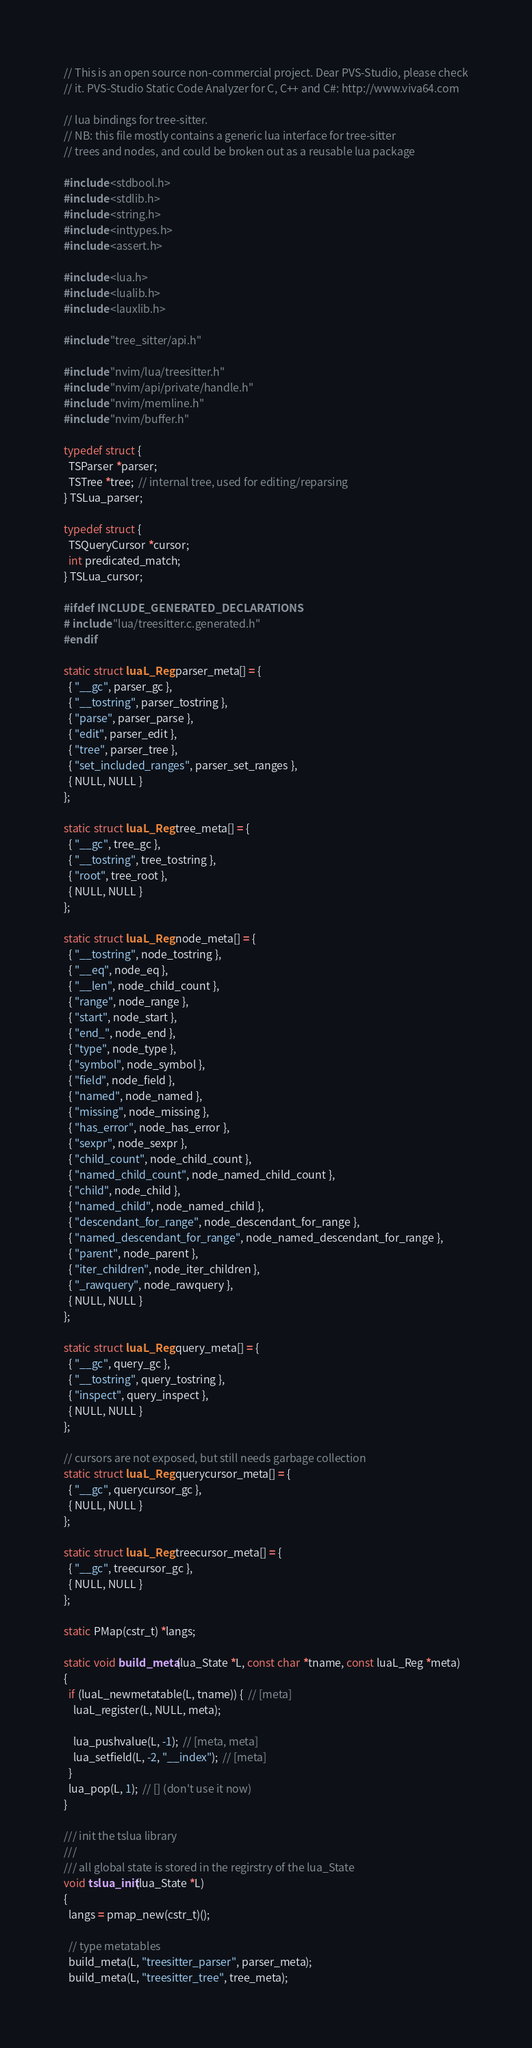Convert code to text. <code><loc_0><loc_0><loc_500><loc_500><_C_>// This is an open source non-commercial project. Dear PVS-Studio, please check
// it. PVS-Studio Static Code Analyzer for C, C++ and C#: http://www.viva64.com

// lua bindings for tree-sitter.
// NB: this file mostly contains a generic lua interface for tree-sitter
// trees and nodes, and could be broken out as a reusable lua package

#include <stdbool.h>
#include <stdlib.h>
#include <string.h>
#include <inttypes.h>
#include <assert.h>

#include <lua.h>
#include <lualib.h>
#include <lauxlib.h>

#include "tree_sitter/api.h"

#include "nvim/lua/treesitter.h"
#include "nvim/api/private/handle.h"
#include "nvim/memline.h"
#include "nvim/buffer.h"

typedef struct {
  TSParser *parser;
  TSTree *tree;  // internal tree, used for editing/reparsing
} TSLua_parser;

typedef struct {
  TSQueryCursor *cursor;
  int predicated_match;
} TSLua_cursor;

#ifdef INCLUDE_GENERATED_DECLARATIONS
# include "lua/treesitter.c.generated.h"
#endif

static struct luaL_Reg parser_meta[] = {
  { "__gc", parser_gc },
  { "__tostring", parser_tostring },
  { "parse", parser_parse },
  { "edit", parser_edit },
  { "tree", parser_tree },
  { "set_included_ranges", parser_set_ranges },
  { NULL, NULL }
};

static struct luaL_Reg tree_meta[] = {
  { "__gc", tree_gc },
  { "__tostring", tree_tostring },
  { "root", tree_root },
  { NULL, NULL }
};

static struct luaL_Reg node_meta[] = {
  { "__tostring", node_tostring },
  { "__eq", node_eq },
  { "__len", node_child_count },
  { "range", node_range },
  { "start", node_start },
  { "end_", node_end },
  { "type", node_type },
  { "symbol", node_symbol },
  { "field", node_field },
  { "named", node_named },
  { "missing", node_missing },
  { "has_error", node_has_error },
  { "sexpr", node_sexpr },
  { "child_count", node_child_count },
  { "named_child_count", node_named_child_count },
  { "child", node_child },
  { "named_child", node_named_child },
  { "descendant_for_range", node_descendant_for_range },
  { "named_descendant_for_range", node_named_descendant_for_range },
  { "parent", node_parent },
  { "iter_children", node_iter_children },
  { "_rawquery", node_rawquery },
  { NULL, NULL }
};

static struct luaL_Reg query_meta[] = {
  { "__gc", query_gc },
  { "__tostring", query_tostring },
  { "inspect", query_inspect },
  { NULL, NULL }
};

// cursors are not exposed, but still needs garbage collection
static struct luaL_Reg querycursor_meta[] = {
  { "__gc", querycursor_gc },
  { NULL, NULL }
};

static struct luaL_Reg treecursor_meta[] = {
  { "__gc", treecursor_gc },
  { NULL, NULL }
};

static PMap(cstr_t) *langs;

static void build_meta(lua_State *L, const char *tname, const luaL_Reg *meta)
{
  if (luaL_newmetatable(L, tname)) {  // [meta]
    luaL_register(L, NULL, meta);

    lua_pushvalue(L, -1);  // [meta, meta]
    lua_setfield(L, -2, "__index");  // [meta]
  }
  lua_pop(L, 1);  // [] (don't use it now)
}

/// init the tslua library
///
/// all global state is stored in the regirstry of the lua_State
void tslua_init(lua_State *L)
{
  langs = pmap_new(cstr_t)();

  // type metatables
  build_meta(L, "treesitter_parser", parser_meta);
  build_meta(L, "treesitter_tree", tree_meta);</code> 